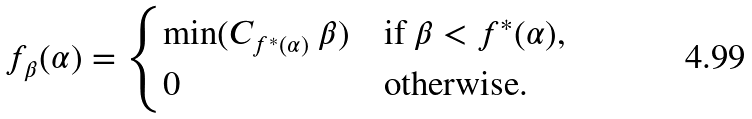Convert formula to latex. <formula><loc_0><loc_0><loc_500><loc_500>f _ { \beta } ( \alpha ) = \begin{cases} \min ( C _ { f ^ { * } ( \alpha ) } \ \beta ) & \text {if $\beta<f^{*}(\alpha)$,} \\ 0 & \text {otherwise.} \end{cases}</formula> 